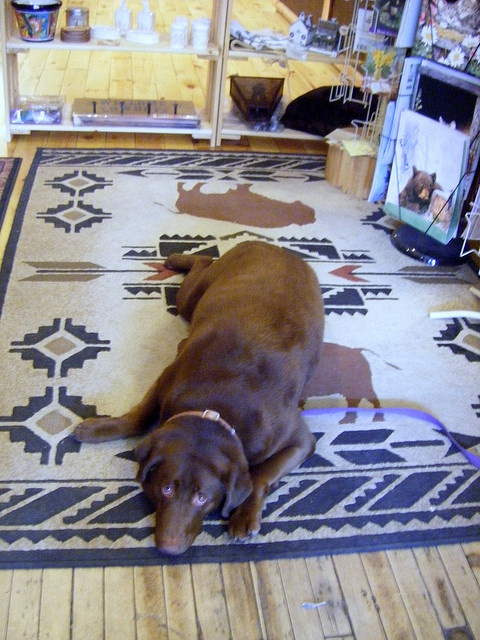Describe the objects in this image and their specific colors. I can see dog in darkgray, gray, black, and maroon tones, book in darkgray, lavender, lightblue, and gray tones, cup in darkgray and lavender tones, and cup in white, lavender, and darkgray tones in this image. 